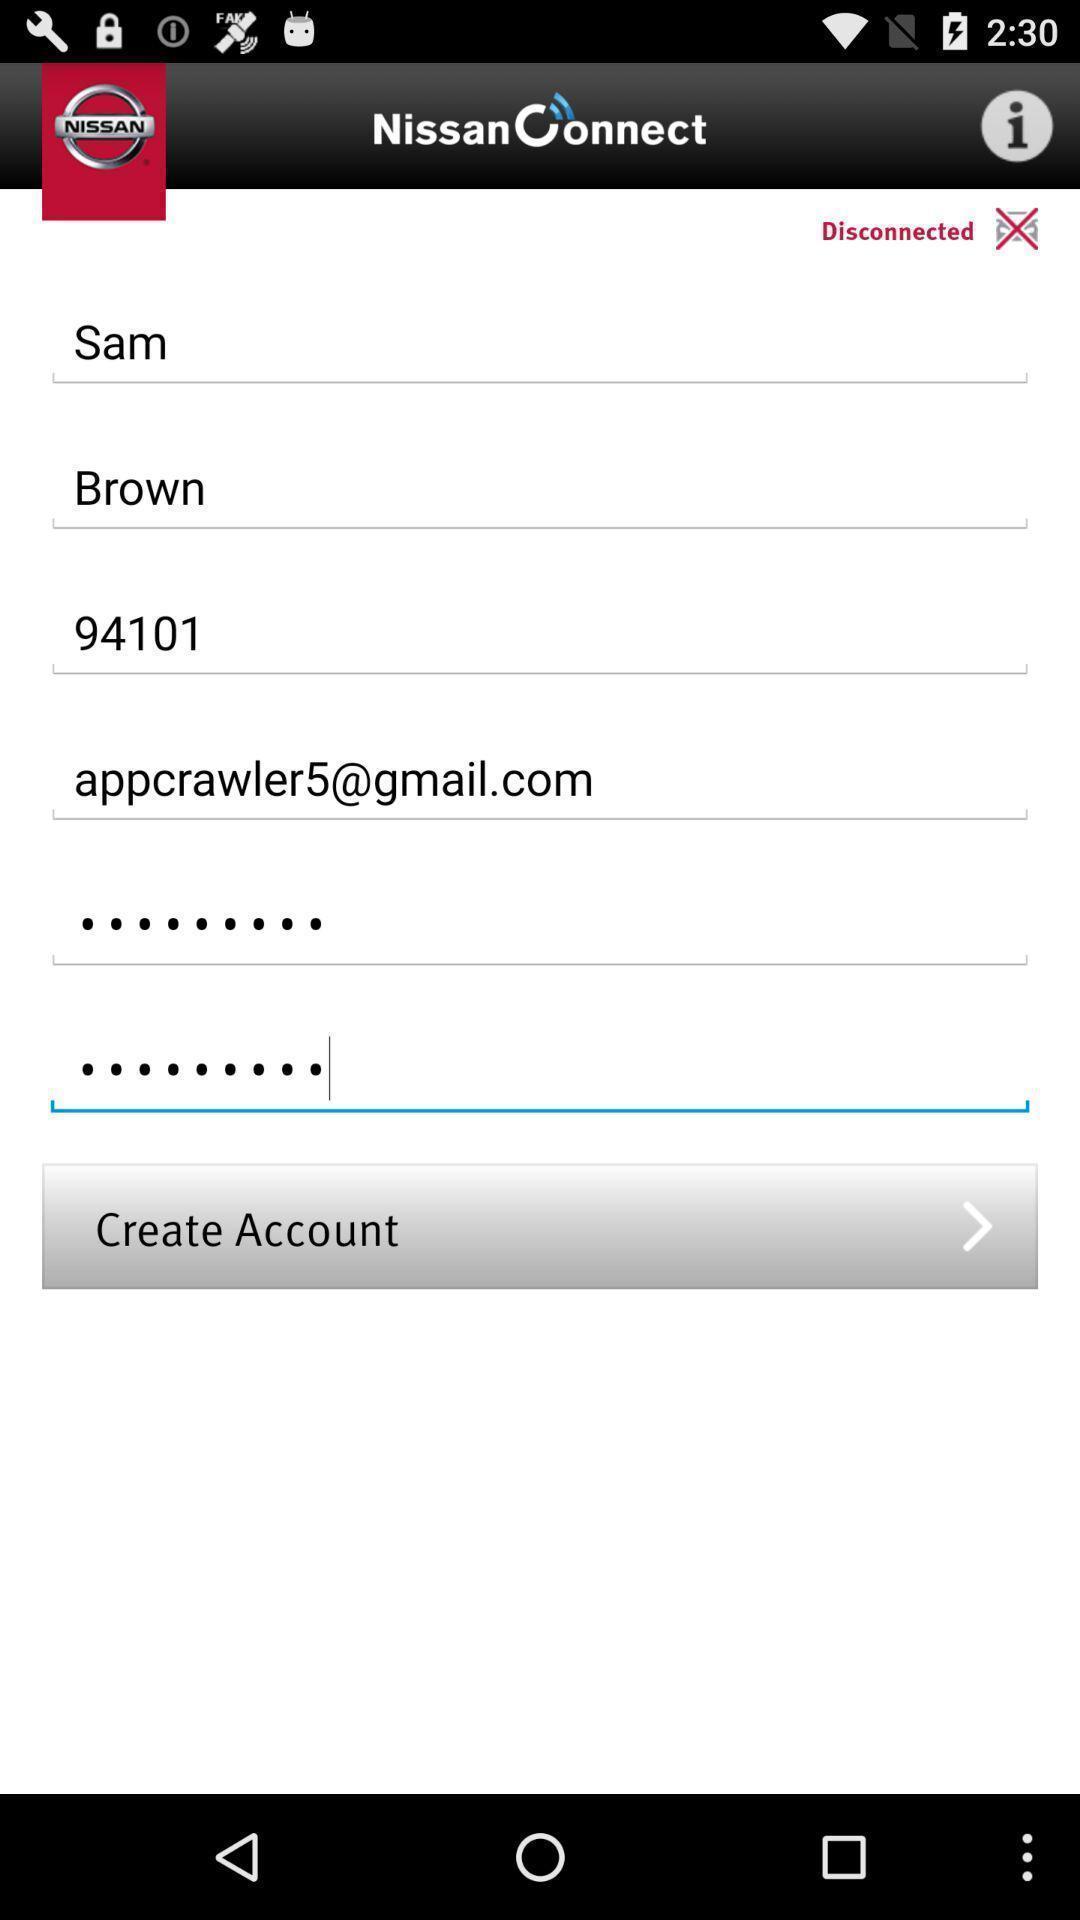What details can you identify in this image? Page showing personal information. 